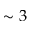Convert formula to latex. <formula><loc_0><loc_0><loc_500><loc_500>\sim 3</formula> 